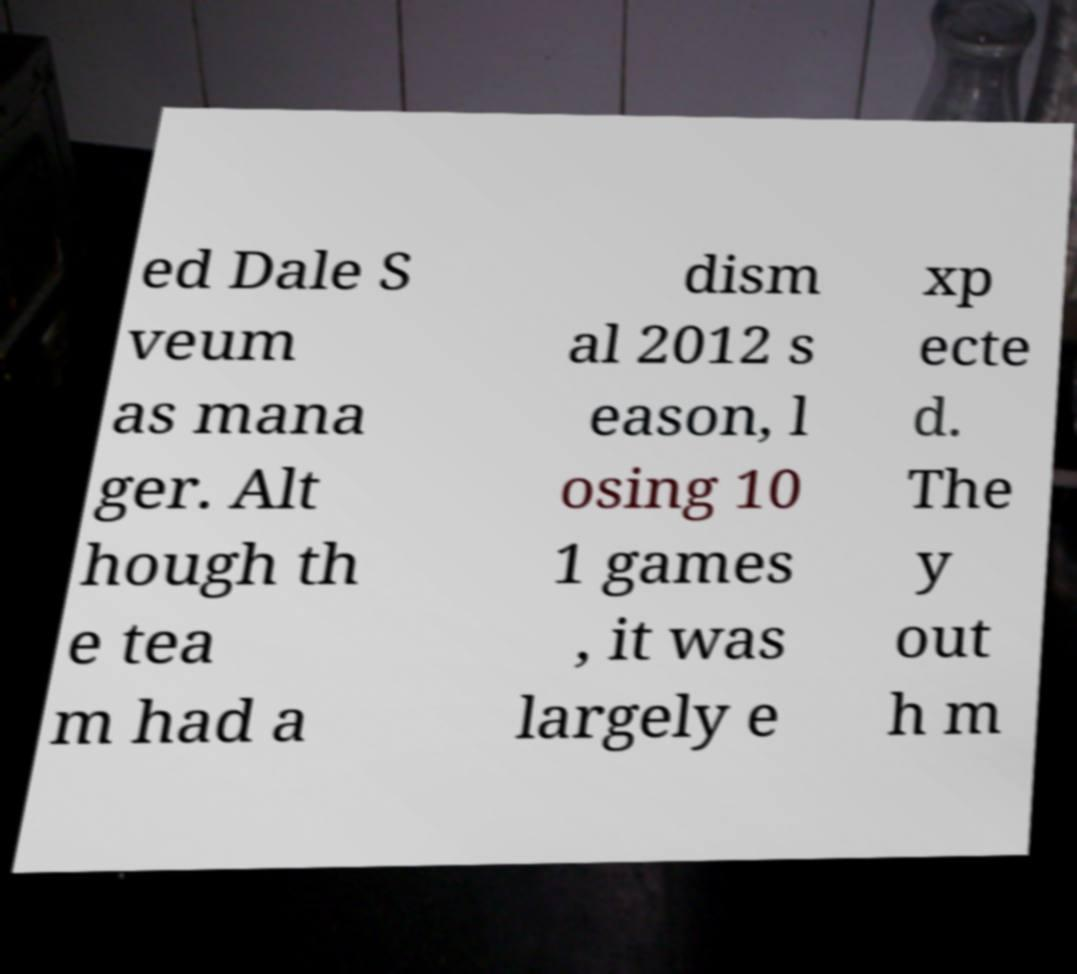Could you assist in decoding the text presented in this image and type it out clearly? ed Dale S veum as mana ger. Alt hough th e tea m had a dism al 2012 s eason, l osing 10 1 games , it was largely e xp ecte d. The y out h m 